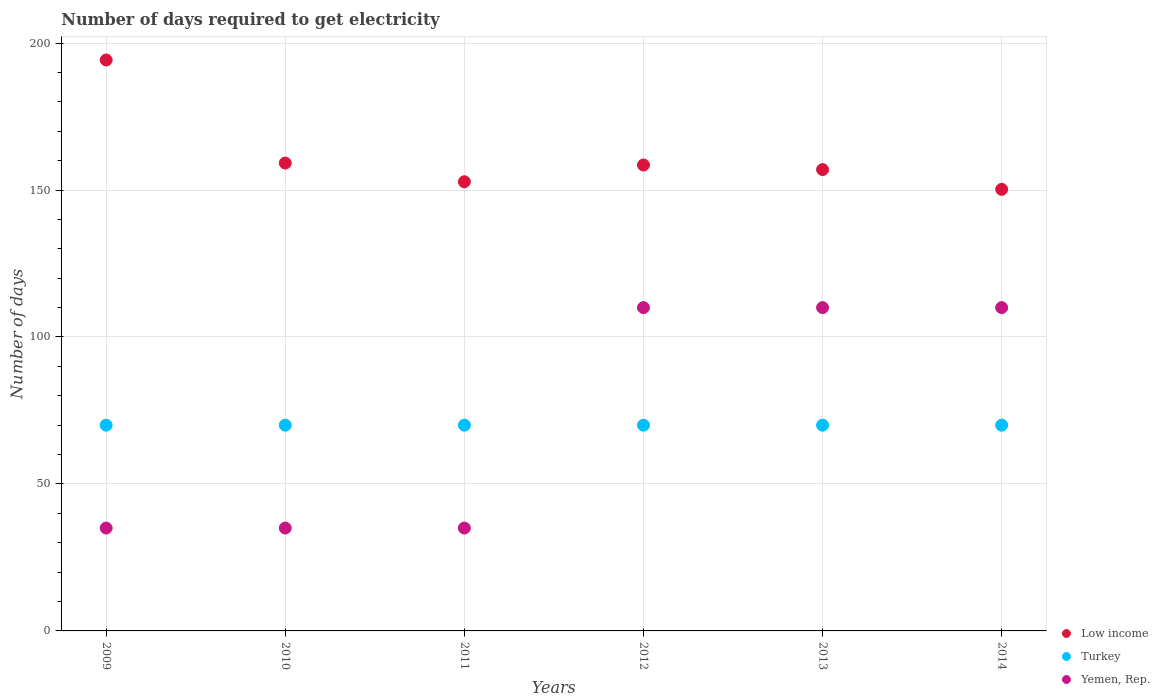Is the number of dotlines equal to the number of legend labels?
Offer a very short reply. Yes. What is the number of days required to get electricity in in Low income in 2011?
Your answer should be compact. 152.82. Across all years, what is the maximum number of days required to get electricity in in Low income?
Offer a terse response. 194.25. Across all years, what is the minimum number of days required to get electricity in in Yemen, Rep.?
Offer a very short reply. 35. In which year was the number of days required to get electricity in in Low income maximum?
Keep it short and to the point. 2009. What is the total number of days required to get electricity in in Turkey in the graph?
Provide a succinct answer. 420. What is the difference between the number of days required to get electricity in in Yemen, Rep. in 2010 and that in 2013?
Your answer should be compact. -75. What is the difference between the number of days required to get electricity in in Yemen, Rep. in 2013 and the number of days required to get electricity in in Turkey in 2009?
Your response must be concise. 40. In the year 2011, what is the difference between the number of days required to get electricity in in Turkey and number of days required to get electricity in in Yemen, Rep.?
Offer a terse response. 35. In how many years, is the number of days required to get electricity in in Low income greater than 190 days?
Offer a terse response. 1. What is the ratio of the number of days required to get electricity in in Turkey in 2009 to that in 2010?
Make the answer very short. 1. Is the difference between the number of days required to get electricity in in Turkey in 2013 and 2014 greater than the difference between the number of days required to get electricity in in Yemen, Rep. in 2013 and 2014?
Provide a succinct answer. No. What is the difference between the highest and the second highest number of days required to get electricity in in Low income?
Offer a very short reply. 35.07. What is the difference between the highest and the lowest number of days required to get electricity in in Turkey?
Provide a short and direct response. 0. Is it the case that in every year, the sum of the number of days required to get electricity in in Turkey and number of days required to get electricity in in Yemen, Rep.  is greater than the number of days required to get electricity in in Low income?
Keep it short and to the point. No. Does the number of days required to get electricity in in Low income monotonically increase over the years?
Give a very brief answer. No. Is the number of days required to get electricity in in Low income strictly less than the number of days required to get electricity in in Yemen, Rep. over the years?
Provide a succinct answer. No. How many dotlines are there?
Provide a short and direct response. 3. What is the difference between two consecutive major ticks on the Y-axis?
Keep it short and to the point. 50. Are the values on the major ticks of Y-axis written in scientific E-notation?
Make the answer very short. No. Does the graph contain any zero values?
Make the answer very short. No. Where does the legend appear in the graph?
Ensure brevity in your answer.  Bottom right. What is the title of the graph?
Offer a terse response. Number of days required to get electricity. What is the label or title of the Y-axis?
Ensure brevity in your answer.  Number of days. What is the Number of days of Low income in 2009?
Provide a succinct answer. 194.25. What is the Number of days in Low income in 2010?
Your answer should be compact. 159.18. What is the Number of days in Low income in 2011?
Provide a short and direct response. 152.82. What is the Number of days of Turkey in 2011?
Offer a very short reply. 70. What is the Number of days in Low income in 2012?
Offer a terse response. 158.52. What is the Number of days in Yemen, Rep. in 2012?
Give a very brief answer. 110. What is the Number of days in Low income in 2013?
Ensure brevity in your answer.  156.97. What is the Number of days of Yemen, Rep. in 2013?
Provide a succinct answer. 110. What is the Number of days of Low income in 2014?
Ensure brevity in your answer.  150.24. What is the Number of days in Yemen, Rep. in 2014?
Offer a terse response. 110. Across all years, what is the maximum Number of days of Low income?
Offer a very short reply. 194.25. Across all years, what is the maximum Number of days in Yemen, Rep.?
Offer a terse response. 110. Across all years, what is the minimum Number of days in Low income?
Give a very brief answer. 150.24. Across all years, what is the minimum Number of days in Yemen, Rep.?
Ensure brevity in your answer.  35. What is the total Number of days in Low income in the graph?
Your response must be concise. 971.97. What is the total Number of days in Turkey in the graph?
Offer a terse response. 420. What is the total Number of days of Yemen, Rep. in the graph?
Offer a terse response. 435. What is the difference between the Number of days of Low income in 2009 and that in 2010?
Provide a short and direct response. 35.07. What is the difference between the Number of days of Low income in 2009 and that in 2011?
Ensure brevity in your answer.  41.43. What is the difference between the Number of days in Turkey in 2009 and that in 2011?
Your answer should be compact. 0. What is the difference between the Number of days of Low income in 2009 and that in 2012?
Ensure brevity in your answer.  35.73. What is the difference between the Number of days of Turkey in 2009 and that in 2012?
Make the answer very short. 0. What is the difference between the Number of days of Yemen, Rep. in 2009 and that in 2012?
Give a very brief answer. -75. What is the difference between the Number of days in Low income in 2009 and that in 2013?
Make the answer very short. 37.28. What is the difference between the Number of days of Yemen, Rep. in 2009 and that in 2013?
Give a very brief answer. -75. What is the difference between the Number of days of Low income in 2009 and that in 2014?
Keep it short and to the point. 44.01. What is the difference between the Number of days in Yemen, Rep. in 2009 and that in 2014?
Your answer should be very brief. -75. What is the difference between the Number of days of Low income in 2010 and that in 2011?
Your response must be concise. 6.36. What is the difference between the Number of days in Low income in 2010 and that in 2012?
Provide a succinct answer. 0.66. What is the difference between the Number of days of Yemen, Rep. in 2010 and that in 2012?
Your response must be concise. -75. What is the difference between the Number of days of Low income in 2010 and that in 2013?
Give a very brief answer. 2.21. What is the difference between the Number of days in Yemen, Rep. in 2010 and that in 2013?
Give a very brief answer. -75. What is the difference between the Number of days of Low income in 2010 and that in 2014?
Give a very brief answer. 8.94. What is the difference between the Number of days in Turkey in 2010 and that in 2014?
Ensure brevity in your answer.  0. What is the difference between the Number of days of Yemen, Rep. in 2010 and that in 2014?
Give a very brief answer. -75. What is the difference between the Number of days in Low income in 2011 and that in 2012?
Offer a terse response. -5.7. What is the difference between the Number of days of Yemen, Rep. in 2011 and that in 2012?
Make the answer very short. -75. What is the difference between the Number of days in Low income in 2011 and that in 2013?
Provide a short and direct response. -4.14. What is the difference between the Number of days of Turkey in 2011 and that in 2013?
Give a very brief answer. 0. What is the difference between the Number of days of Yemen, Rep. in 2011 and that in 2013?
Keep it short and to the point. -75. What is the difference between the Number of days in Low income in 2011 and that in 2014?
Ensure brevity in your answer.  2.58. What is the difference between the Number of days of Turkey in 2011 and that in 2014?
Offer a very short reply. 0. What is the difference between the Number of days in Yemen, Rep. in 2011 and that in 2014?
Your response must be concise. -75. What is the difference between the Number of days in Low income in 2012 and that in 2013?
Offer a terse response. 1.55. What is the difference between the Number of days in Turkey in 2012 and that in 2013?
Your answer should be very brief. 0. What is the difference between the Number of days in Low income in 2012 and that in 2014?
Offer a terse response. 8.28. What is the difference between the Number of days of Yemen, Rep. in 2012 and that in 2014?
Your answer should be very brief. 0. What is the difference between the Number of days in Low income in 2013 and that in 2014?
Ensure brevity in your answer.  6.72. What is the difference between the Number of days in Turkey in 2013 and that in 2014?
Your answer should be compact. 0. What is the difference between the Number of days of Yemen, Rep. in 2013 and that in 2014?
Make the answer very short. 0. What is the difference between the Number of days of Low income in 2009 and the Number of days of Turkey in 2010?
Offer a terse response. 124.25. What is the difference between the Number of days in Low income in 2009 and the Number of days in Yemen, Rep. in 2010?
Your answer should be very brief. 159.25. What is the difference between the Number of days in Turkey in 2009 and the Number of days in Yemen, Rep. in 2010?
Keep it short and to the point. 35. What is the difference between the Number of days in Low income in 2009 and the Number of days in Turkey in 2011?
Your answer should be very brief. 124.25. What is the difference between the Number of days of Low income in 2009 and the Number of days of Yemen, Rep. in 2011?
Keep it short and to the point. 159.25. What is the difference between the Number of days of Low income in 2009 and the Number of days of Turkey in 2012?
Offer a very short reply. 124.25. What is the difference between the Number of days of Low income in 2009 and the Number of days of Yemen, Rep. in 2012?
Keep it short and to the point. 84.25. What is the difference between the Number of days in Low income in 2009 and the Number of days in Turkey in 2013?
Provide a succinct answer. 124.25. What is the difference between the Number of days in Low income in 2009 and the Number of days in Yemen, Rep. in 2013?
Offer a very short reply. 84.25. What is the difference between the Number of days of Turkey in 2009 and the Number of days of Yemen, Rep. in 2013?
Offer a very short reply. -40. What is the difference between the Number of days of Low income in 2009 and the Number of days of Turkey in 2014?
Your answer should be compact. 124.25. What is the difference between the Number of days in Low income in 2009 and the Number of days in Yemen, Rep. in 2014?
Keep it short and to the point. 84.25. What is the difference between the Number of days in Turkey in 2009 and the Number of days in Yemen, Rep. in 2014?
Keep it short and to the point. -40. What is the difference between the Number of days in Low income in 2010 and the Number of days in Turkey in 2011?
Offer a very short reply. 89.18. What is the difference between the Number of days in Low income in 2010 and the Number of days in Yemen, Rep. in 2011?
Your answer should be very brief. 124.18. What is the difference between the Number of days of Turkey in 2010 and the Number of days of Yemen, Rep. in 2011?
Give a very brief answer. 35. What is the difference between the Number of days in Low income in 2010 and the Number of days in Turkey in 2012?
Keep it short and to the point. 89.18. What is the difference between the Number of days in Low income in 2010 and the Number of days in Yemen, Rep. in 2012?
Make the answer very short. 49.18. What is the difference between the Number of days in Turkey in 2010 and the Number of days in Yemen, Rep. in 2012?
Provide a succinct answer. -40. What is the difference between the Number of days in Low income in 2010 and the Number of days in Turkey in 2013?
Ensure brevity in your answer.  89.18. What is the difference between the Number of days in Low income in 2010 and the Number of days in Yemen, Rep. in 2013?
Offer a very short reply. 49.18. What is the difference between the Number of days in Low income in 2010 and the Number of days in Turkey in 2014?
Offer a very short reply. 89.18. What is the difference between the Number of days in Low income in 2010 and the Number of days in Yemen, Rep. in 2014?
Make the answer very short. 49.18. What is the difference between the Number of days in Low income in 2011 and the Number of days in Turkey in 2012?
Make the answer very short. 82.82. What is the difference between the Number of days in Low income in 2011 and the Number of days in Yemen, Rep. in 2012?
Keep it short and to the point. 42.82. What is the difference between the Number of days of Low income in 2011 and the Number of days of Turkey in 2013?
Give a very brief answer. 82.82. What is the difference between the Number of days in Low income in 2011 and the Number of days in Yemen, Rep. in 2013?
Your answer should be very brief. 42.82. What is the difference between the Number of days in Turkey in 2011 and the Number of days in Yemen, Rep. in 2013?
Provide a short and direct response. -40. What is the difference between the Number of days of Low income in 2011 and the Number of days of Turkey in 2014?
Offer a terse response. 82.82. What is the difference between the Number of days in Low income in 2011 and the Number of days in Yemen, Rep. in 2014?
Provide a short and direct response. 42.82. What is the difference between the Number of days of Low income in 2012 and the Number of days of Turkey in 2013?
Keep it short and to the point. 88.52. What is the difference between the Number of days in Low income in 2012 and the Number of days in Yemen, Rep. in 2013?
Provide a short and direct response. 48.52. What is the difference between the Number of days in Turkey in 2012 and the Number of days in Yemen, Rep. in 2013?
Your answer should be very brief. -40. What is the difference between the Number of days in Low income in 2012 and the Number of days in Turkey in 2014?
Provide a short and direct response. 88.52. What is the difference between the Number of days of Low income in 2012 and the Number of days of Yemen, Rep. in 2014?
Provide a short and direct response. 48.52. What is the difference between the Number of days of Low income in 2013 and the Number of days of Turkey in 2014?
Your answer should be very brief. 86.97. What is the difference between the Number of days of Low income in 2013 and the Number of days of Yemen, Rep. in 2014?
Provide a succinct answer. 46.97. What is the difference between the Number of days of Turkey in 2013 and the Number of days of Yemen, Rep. in 2014?
Your answer should be compact. -40. What is the average Number of days in Low income per year?
Make the answer very short. 162. What is the average Number of days in Turkey per year?
Provide a succinct answer. 70. What is the average Number of days in Yemen, Rep. per year?
Ensure brevity in your answer.  72.5. In the year 2009, what is the difference between the Number of days of Low income and Number of days of Turkey?
Your answer should be compact. 124.25. In the year 2009, what is the difference between the Number of days in Low income and Number of days in Yemen, Rep.?
Offer a very short reply. 159.25. In the year 2010, what is the difference between the Number of days of Low income and Number of days of Turkey?
Provide a short and direct response. 89.18. In the year 2010, what is the difference between the Number of days in Low income and Number of days in Yemen, Rep.?
Give a very brief answer. 124.18. In the year 2011, what is the difference between the Number of days in Low income and Number of days in Turkey?
Keep it short and to the point. 82.82. In the year 2011, what is the difference between the Number of days of Low income and Number of days of Yemen, Rep.?
Your response must be concise. 117.82. In the year 2012, what is the difference between the Number of days in Low income and Number of days in Turkey?
Keep it short and to the point. 88.52. In the year 2012, what is the difference between the Number of days in Low income and Number of days in Yemen, Rep.?
Offer a terse response. 48.52. In the year 2013, what is the difference between the Number of days of Low income and Number of days of Turkey?
Ensure brevity in your answer.  86.97. In the year 2013, what is the difference between the Number of days of Low income and Number of days of Yemen, Rep.?
Keep it short and to the point. 46.97. In the year 2014, what is the difference between the Number of days of Low income and Number of days of Turkey?
Your response must be concise. 80.24. In the year 2014, what is the difference between the Number of days in Low income and Number of days in Yemen, Rep.?
Your answer should be compact. 40.24. What is the ratio of the Number of days in Low income in 2009 to that in 2010?
Your response must be concise. 1.22. What is the ratio of the Number of days in Yemen, Rep. in 2009 to that in 2010?
Your answer should be very brief. 1. What is the ratio of the Number of days of Low income in 2009 to that in 2011?
Make the answer very short. 1.27. What is the ratio of the Number of days of Low income in 2009 to that in 2012?
Provide a short and direct response. 1.23. What is the ratio of the Number of days in Turkey in 2009 to that in 2012?
Give a very brief answer. 1. What is the ratio of the Number of days in Yemen, Rep. in 2009 to that in 2012?
Your answer should be compact. 0.32. What is the ratio of the Number of days of Low income in 2009 to that in 2013?
Give a very brief answer. 1.24. What is the ratio of the Number of days in Turkey in 2009 to that in 2013?
Give a very brief answer. 1. What is the ratio of the Number of days in Yemen, Rep. in 2009 to that in 2013?
Your answer should be very brief. 0.32. What is the ratio of the Number of days of Low income in 2009 to that in 2014?
Provide a short and direct response. 1.29. What is the ratio of the Number of days in Turkey in 2009 to that in 2014?
Offer a terse response. 1. What is the ratio of the Number of days of Yemen, Rep. in 2009 to that in 2014?
Make the answer very short. 0.32. What is the ratio of the Number of days in Low income in 2010 to that in 2011?
Your response must be concise. 1.04. What is the ratio of the Number of days in Low income in 2010 to that in 2012?
Give a very brief answer. 1. What is the ratio of the Number of days in Turkey in 2010 to that in 2012?
Offer a terse response. 1. What is the ratio of the Number of days in Yemen, Rep. in 2010 to that in 2012?
Provide a succinct answer. 0.32. What is the ratio of the Number of days in Low income in 2010 to that in 2013?
Keep it short and to the point. 1.01. What is the ratio of the Number of days of Turkey in 2010 to that in 2013?
Provide a succinct answer. 1. What is the ratio of the Number of days of Yemen, Rep. in 2010 to that in 2013?
Provide a short and direct response. 0.32. What is the ratio of the Number of days in Low income in 2010 to that in 2014?
Provide a short and direct response. 1.06. What is the ratio of the Number of days of Turkey in 2010 to that in 2014?
Provide a succinct answer. 1. What is the ratio of the Number of days of Yemen, Rep. in 2010 to that in 2014?
Ensure brevity in your answer.  0.32. What is the ratio of the Number of days in Low income in 2011 to that in 2012?
Your answer should be very brief. 0.96. What is the ratio of the Number of days in Turkey in 2011 to that in 2012?
Keep it short and to the point. 1. What is the ratio of the Number of days of Yemen, Rep. in 2011 to that in 2012?
Your answer should be very brief. 0.32. What is the ratio of the Number of days in Low income in 2011 to that in 2013?
Your answer should be compact. 0.97. What is the ratio of the Number of days in Turkey in 2011 to that in 2013?
Provide a succinct answer. 1. What is the ratio of the Number of days in Yemen, Rep. in 2011 to that in 2013?
Your response must be concise. 0.32. What is the ratio of the Number of days in Low income in 2011 to that in 2014?
Keep it short and to the point. 1.02. What is the ratio of the Number of days in Yemen, Rep. in 2011 to that in 2014?
Your answer should be compact. 0.32. What is the ratio of the Number of days in Low income in 2012 to that in 2013?
Your answer should be compact. 1.01. What is the ratio of the Number of days in Low income in 2012 to that in 2014?
Make the answer very short. 1.06. What is the ratio of the Number of days in Turkey in 2012 to that in 2014?
Provide a short and direct response. 1. What is the ratio of the Number of days in Low income in 2013 to that in 2014?
Offer a terse response. 1.04. What is the difference between the highest and the second highest Number of days in Low income?
Make the answer very short. 35.07. What is the difference between the highest and the lowest Number of days in Low income?
Provide a short and direct response. 44.01. What is the difference between the highest and the lowest Number of days in Yemen, Rep.?
Your answer should be very brief. 75. 